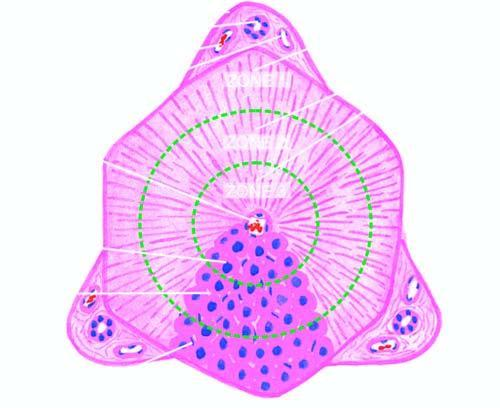what is termed the classical lobule?
Answer the question using a single word or phrase. Central vein and peripheral 4 to 5 portal triads 